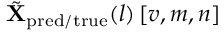Convert formula to latex. <formula><loc_0><loc_0><loc_500><loc_500>\tilde { X } _ { p r e d / t r u e } ( l ) \left [ v , m , n \right ]</formula> 